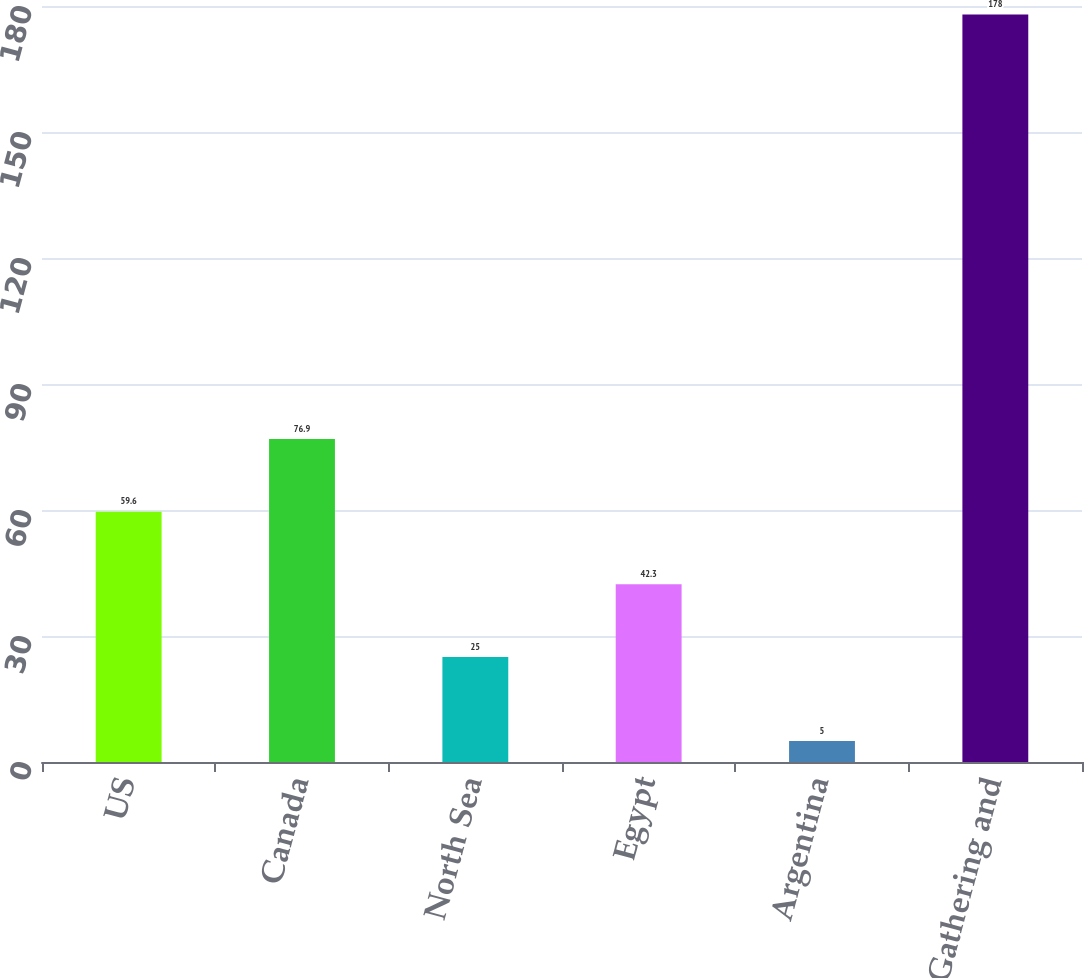Convert chart. <chart><loc_0><loc_0><loc_500><loc_500><bar_chart><fcel>US<fcel>Canada<fcel>North Sea<fcel>Egypt<fcel>Argentina<fcel>Total Gathering and<nl><fcel>59.6<fcel>76.9<fcel>25<fcel>42.3<fcel>5<fcel>178<nl></chart> 